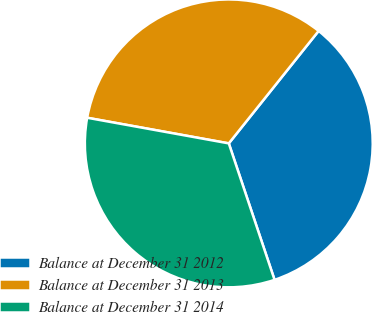<chart> <loc_0><loc_0><loc_500><loc_500><pie_chart><fcel>Balance at December 31 2012<fcel>Balance at December 31 2013<fcel>Balance at December 31 2014<nl><fcel>34.12%<fcel>32.88%<fcel>33.0%<nl></chart> 